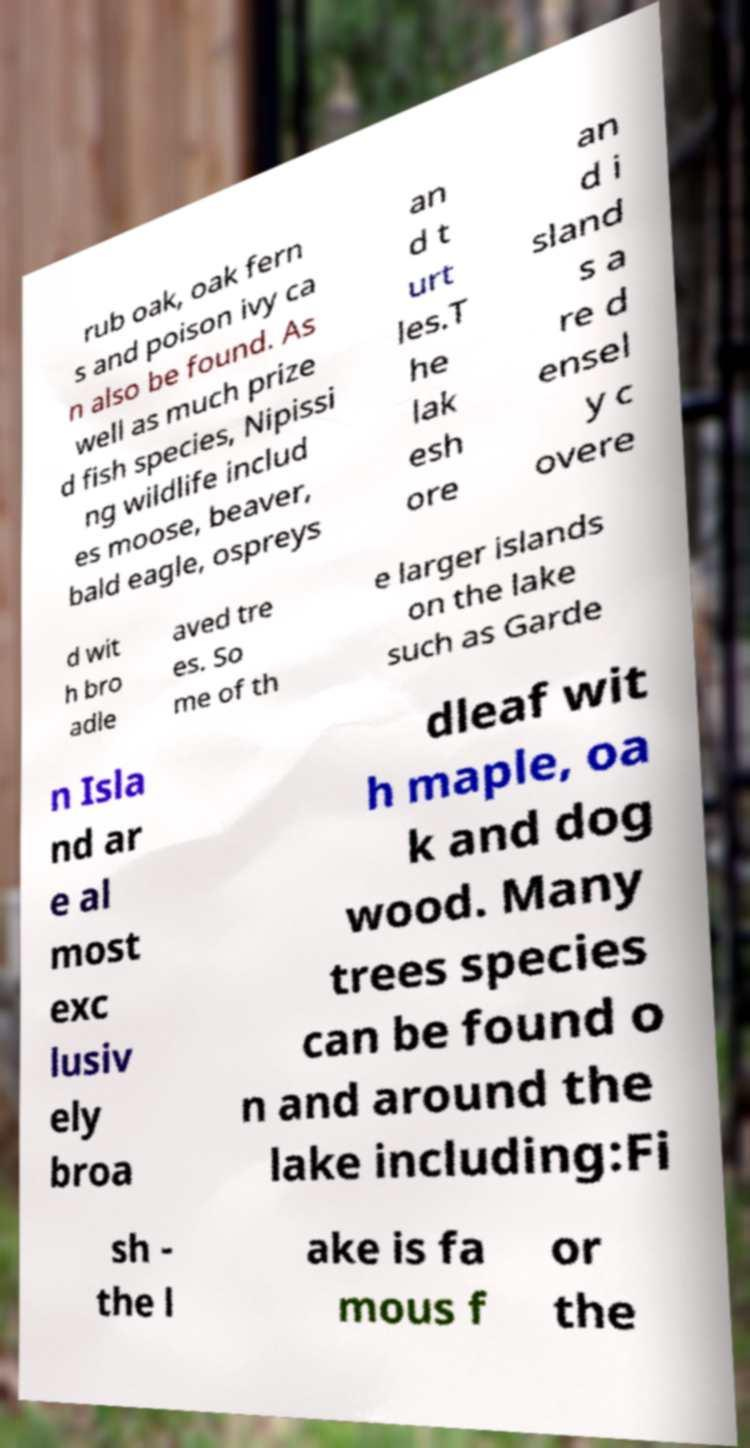There's text embedded in this image that I need extracted. Can you transcribe it verbatim? rub oak, oak fern s and poison ivy ca n also be found. As well as much prize d fish species, Nipissi ng wildlife includ es moose, beaver, bald eagle, ospreys an d t urt les.T he lak esh ore an d i sland s a re d ensel y c overe d wit h bro adle aved tre es. So me of th e larger islands on the lake such as Garde n Isla nd ar e al most exc lusiv ely broa dleaf wit h maple, oa k and dog wood. Many trees species can be found o n and around the lake including:Fi sh - the l ake is fa mous f or the 